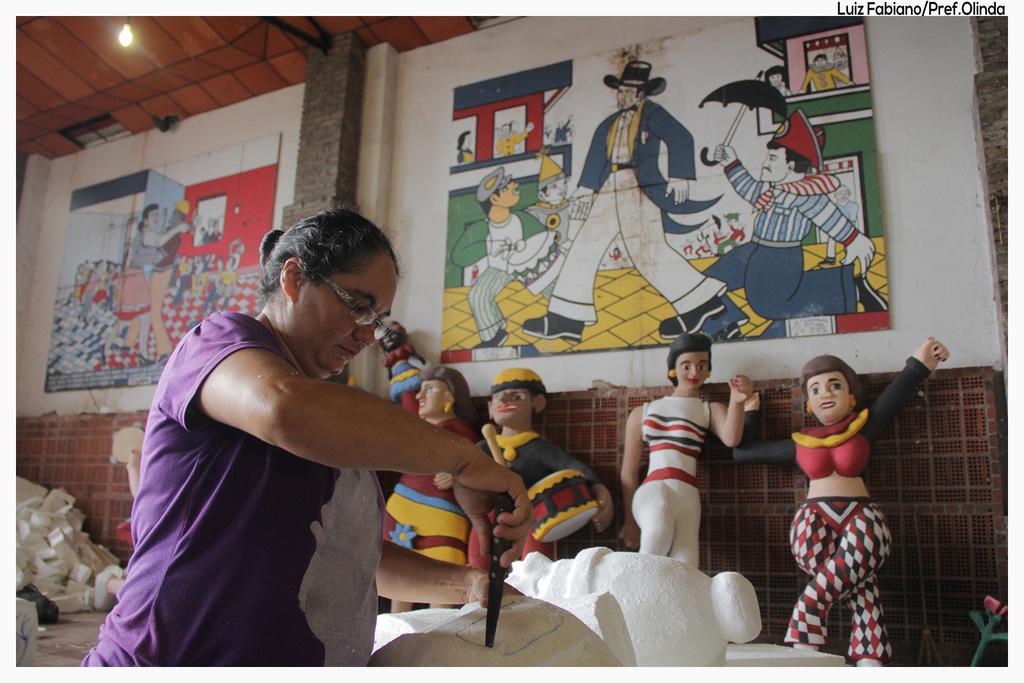How would you summarize this image in a sentence or two? In this image there is a lady standing and holding a knife in her hand and placed it on an object, which are on the table. In the background there are few toys and few objects are on the floor, there are few frames hanging on the wall. At the top of the image there is a ceiling and a light. 